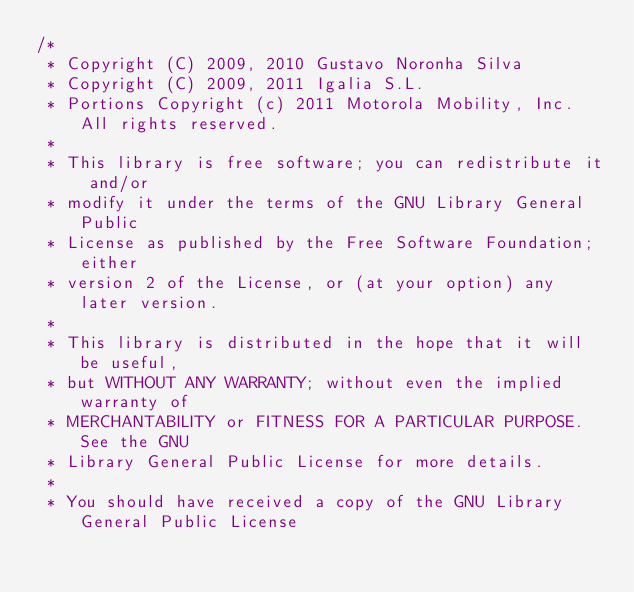<code> <loc_0><loc_0><loc_500><loc_500><_C++_>/*
 * Copyright (C) 2009, 2010 Gustavo Noronha Silva
 * Copyright (C) 2009, 2011 Igalia S.L.
 * Portions Copyright (c) 2011 Motorola Mobility, Inc.  All rights reserved.
 *
 * This library is free software; you can redistribute it and/or
 * modify it under the terms of the GNU Library General Public
 * License as published by the Free Software Foundation; either
 * version 2 of the License, or (at your option) any later version.
 *
 * This library is distributed in the hope that it will be useful,
 * but WITHOUT ANY WARRANTY; without even the implied warranty of
 * MERCHANTABILITY or FITNESS FOR A PARTICULAR PURPOSE.  See the GNU
 * Library General Public License for more details.
 *
 * You should have received a copy of the GNU Library General Public License</code> 